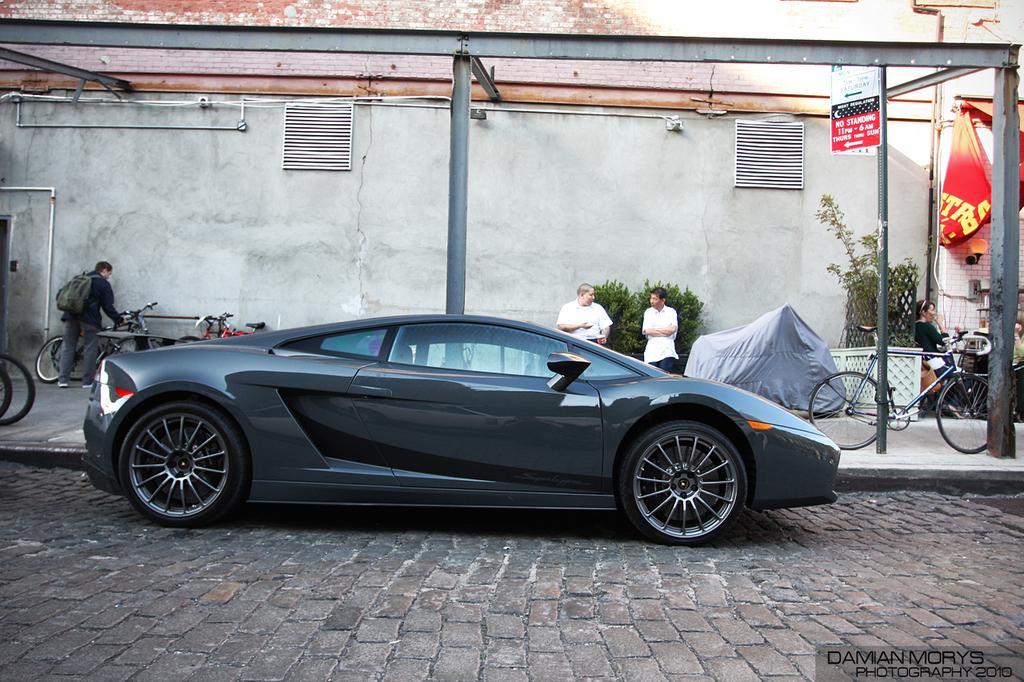Can you describe this image briefly? This image is taken outdoors. At the bottom of the image there is a road. In the background there is a wall with two ventilators and there are a few pipelines. There are a few iron bars and there is a board with a text on it. In the middle of the image a car is parked on the road. Two men are standing on the sidewalk and a few bicycles are parked on the sidewalk. A man is holding a bicycle. There is a plant. On the right side of the image there is a banner with a text on it. A woman is sitting on the chair and there is a table with a few things on it. 